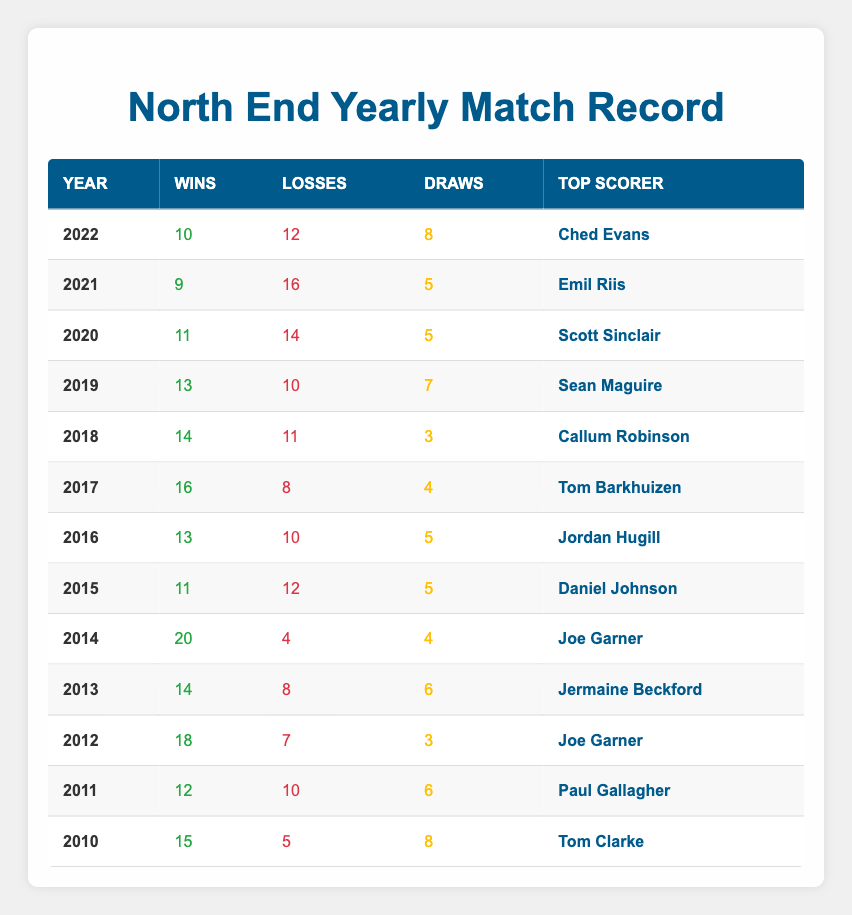What year did North End have the highest number of wins? The table shows that in 2014, North End had 20 wins, which is the highest compared to other years listed.
Answer: 2014 What is the total number of losses in 2019 and 2020? In 2019, North End had 10 losses and in 2020, they had 14 losses. Adding these gives 10 + 14 = 24 losses.
Answer: 24 Who was the top scorer in 2015? According to the table, the top scorer for North End in 2015 was Daniel Johnson.
Answer: Daniel Johnson Did North End lose more than 15 matches in any year? Checking the losses in each year, in 2021 they lost 16 matches, which is more than 15.
Answer: Yes What was the average number of wins for North End from 2010 to 2015? The total wins from 2010 to 2015 are 15 + 12 + 18 + 14 + 20 + 11 = 90. There are 6 years, so the average is 90 / 6 = 15.
Answer: 15 In which years did Joe Garner serve as the top scorer? Joe Garner was the top scorer in 2012 and 2014. These are the only years mentioned in the table for him.
Answer: 2012, 2014 How many draws did North End have in 2017 and 2018 combined? For 2017, North End had 4 draws, and in 2018 they had 3 draws. Adding these gives 4 + 3 = 7 draws combined.
Answer: 7 Is it true that North End had a losing record (more losses than wins) in 2021? In 2021, North End had 9 wins and 16 losses, which indicates a losing record since losses outnumber wins.
Answer: Yes What was the difference in wins between 2012 and 2016? In 2012, North End had 18 wins, while in 2016, they had 13 wins. The difference is 18 - 13 = 5 wins.
Answer: 5 